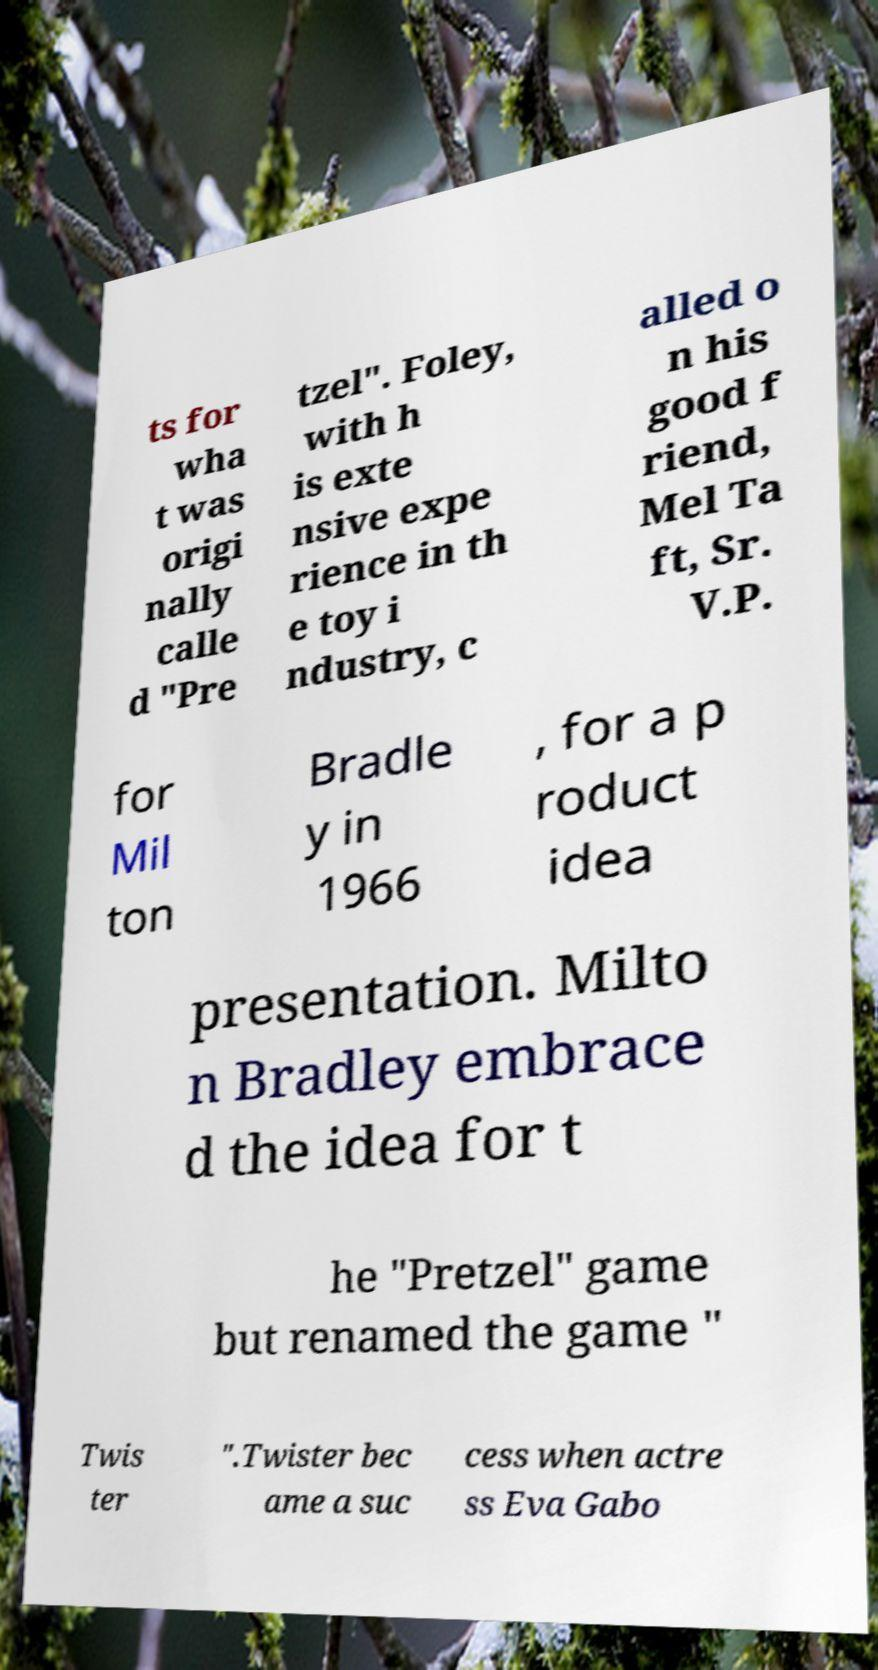I need the written content from this picture converted into text. Can you do that? ts for wha t was origi nally calle d "Pre tzel". Foley, with h is exte nsive expe rience in th e toy i ndustry, c alled o n his good f riend, Mel Ta ft, Sr. V.P. for Mil ton Bradle y in 1966 , for a p roduct idea presentation. Milto n Bradley embrace d the idea for t he "Pretzel" game but renamed the game " Twis ter ".Twister bec ame a suc cess when actre ss Eva Gabo 